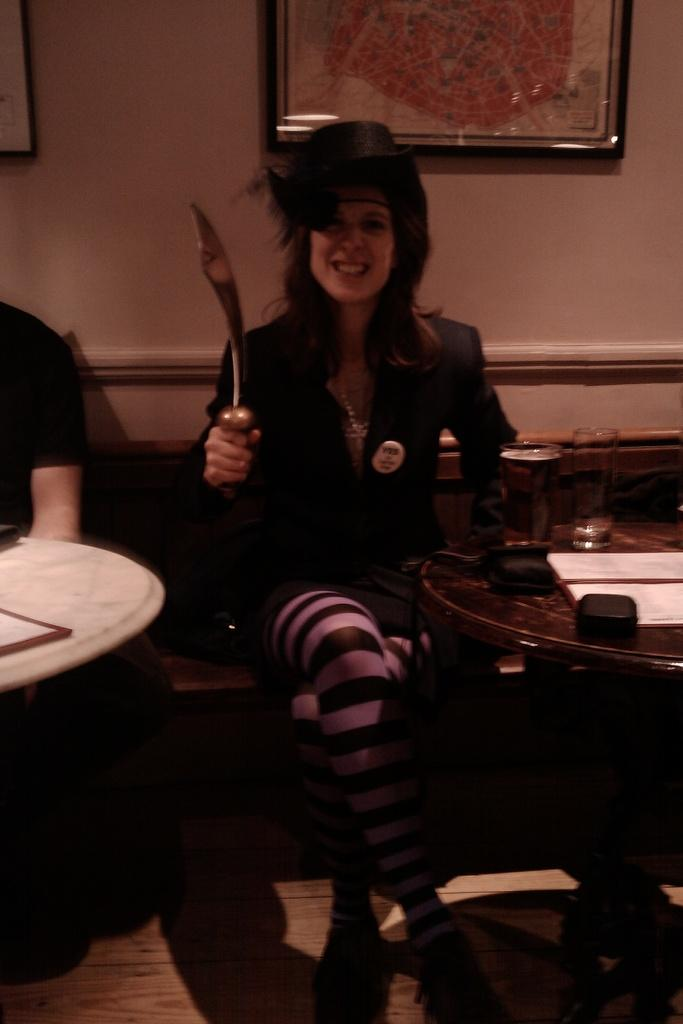What is the woman in the image doing? The woman is sitting on a bench in the image. What is the woman holding in her hand? The woman is holding a knife in the image. What is in front of the woman? There is a table in front of the woman in the image. What can be seen on the table? There are objects on the table in the image. Who is sitting beside the woman? There is a person sitting beside the woman in the image. What type of battle is taking place in the image? There is no battle present in the image; it features a woman sitting on a bench with a knife and a table with objects. What is the source of the smoke in the image? There is no smoke present in the image. 